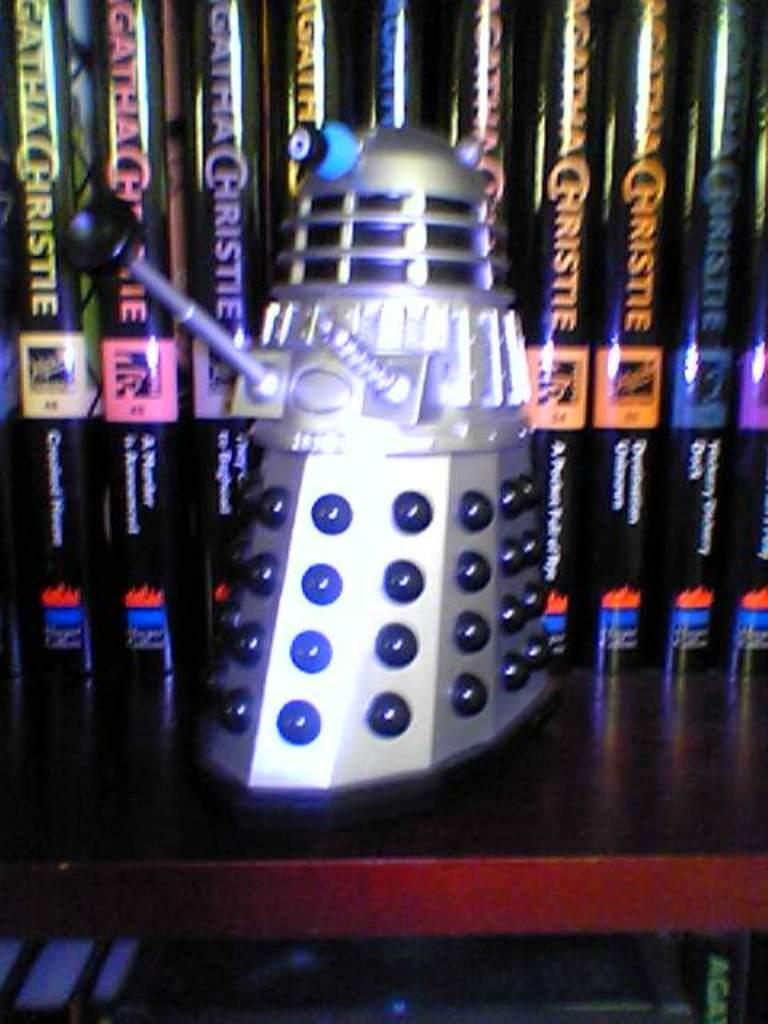<image>
Create a compact narrative representing the image presented. A model robot is on a shelf in front of books by Agatha Christie. 